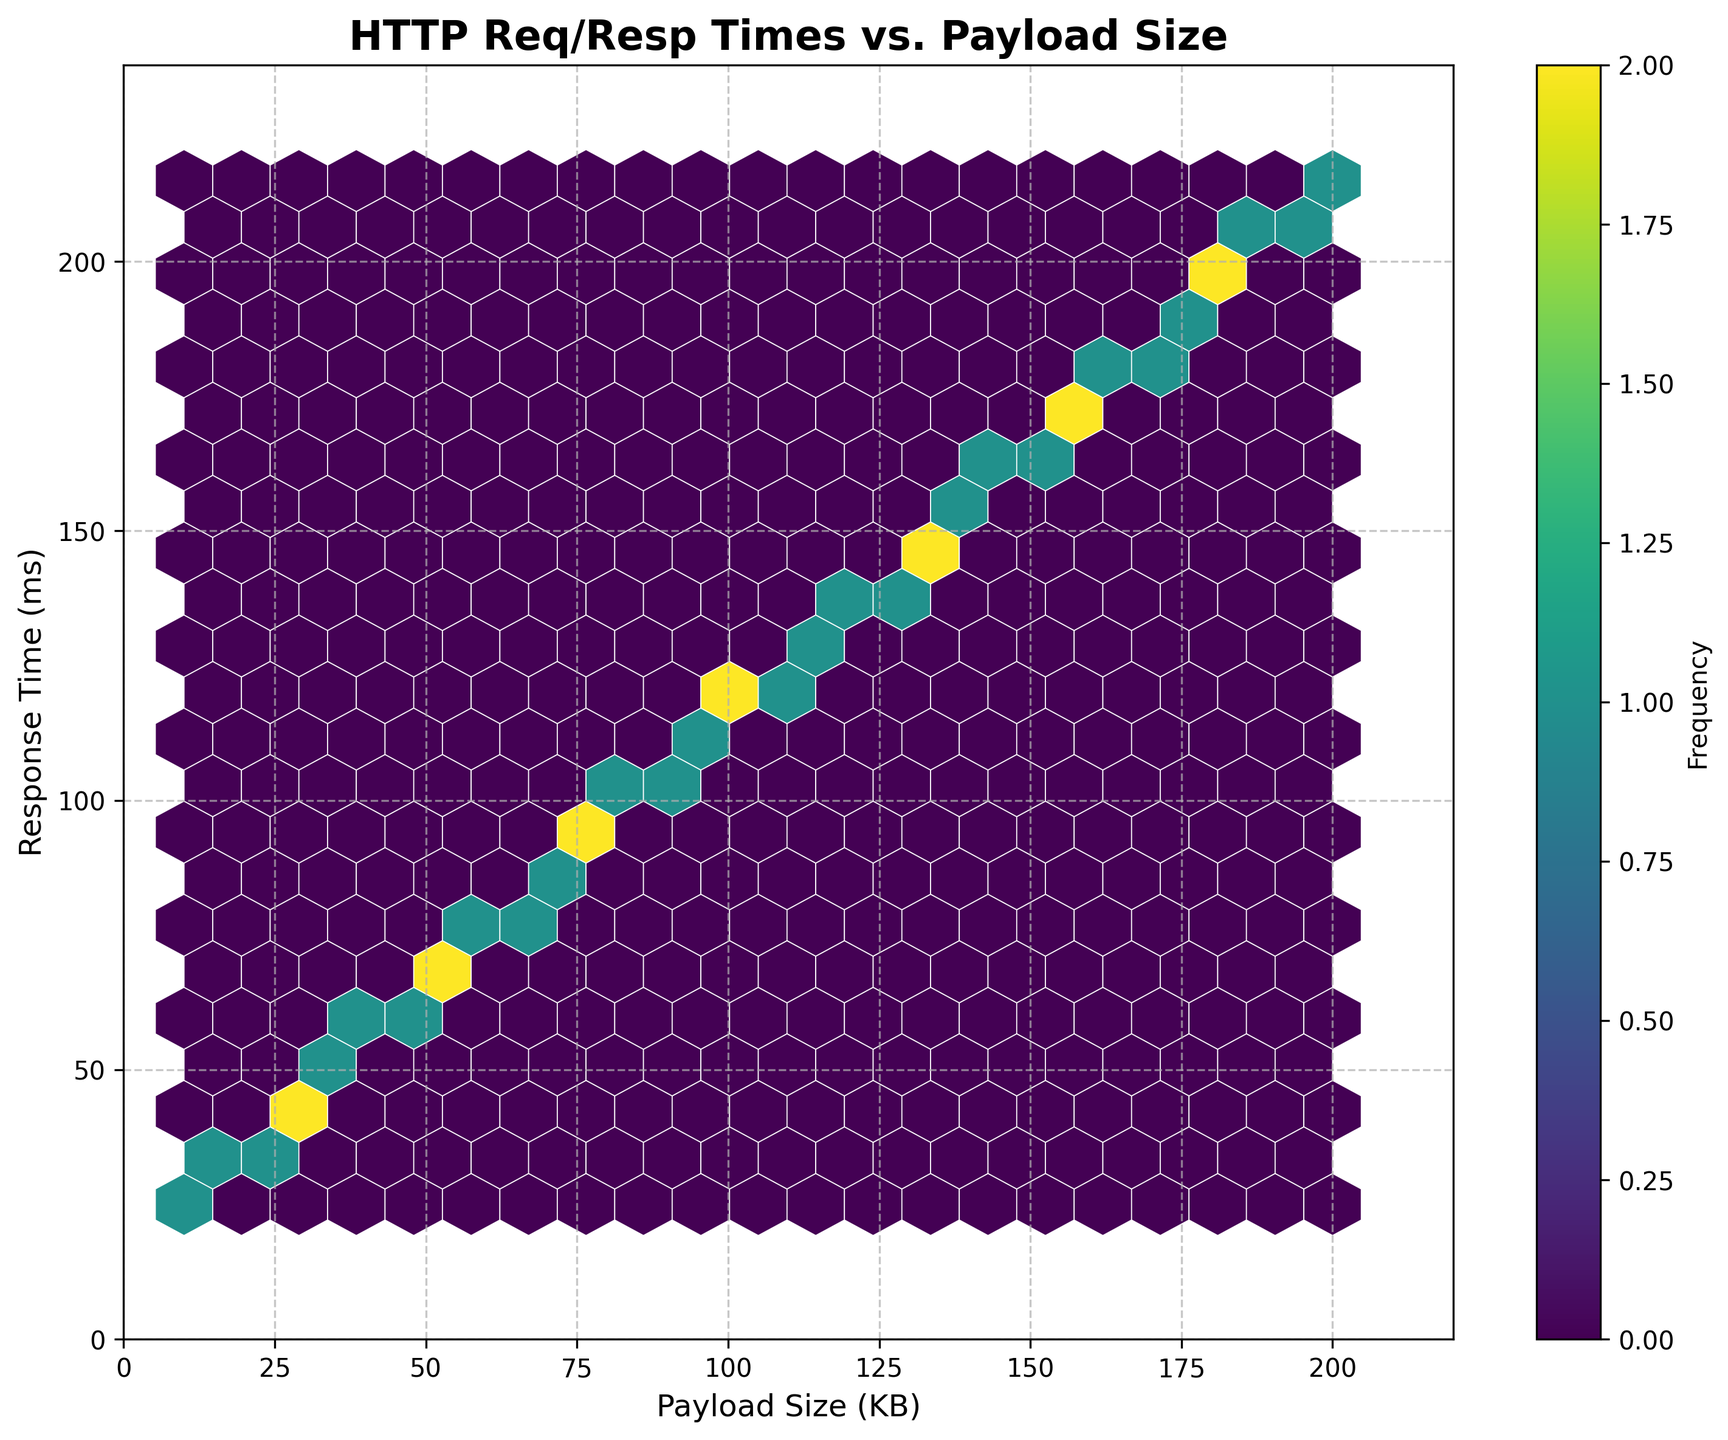How many hexagons are displayed in the plot? Count the number of hexagons visible on the plot. The gridsize is set to 20, which typically results in 20x20 hexagons, but some are empty.
Answer: 24 What are the labels of the x-axis and y-axis? Read the labels on the x-axis and y-axis in the plot. The x-axis is labeled "Payload Size (KB)" and the y-axis is labeled "Response Time (ms)".
Answer: Payload Size (KB) and Response Time (ms) What is the title of the plot? Look at the title placed above the plot. The title is "HTTP Req/Resp Times vs. Payload Size".
Answer: HTTP Req/Resp Times vs. Payload Size Which color represents the highest frequency of data points? Observe the color bar to understand which color represents the highest frequency. The darkest color in the 'viridis' colormap corresponds to the highest frequency.
Answer: Dark purple Is there a grid in the plot, and if so, what is its style? Notice the presence of a grid and its style. The gridlines are present and styled with dashed lines (--) and have an alpha (transparency) value of 0.7.
Answer: Dashed, transparent lines What is the approximate relationship between payload size and response time as shown in the plot? Look at the general trend of the hexagons in the plot. As payload size increases, response time also increases linearly.
Answer: Linear increase What's the range of payload sizes displayed in the plot? Check the x-axis limits and any additional scaling. The x-axis ranges from 0 to approximately 220 KB (including a 10% buffer).
Answer: 0 to 220 KB What is the range of response times displayed in the plot? Check the y-axis limits and any additional scaling. The y-axis ranges from 0 to approximately 240 ms (including a 10% buffer).
Answer: 0 to 240 ms Are there any outliers or anomalies in the plotted data? Look for any hexagons that stand out significantly from the trend or are isolated. There are no noticeable outliers or anomalies; the data follows a consistent linear pattern.
Answer: No outliers or anomalies Is there a color bar legend, and what does it represent? Check the right side of the plot for a color bar. The color bar is present and indicates the frequency of data points within each hexagon.
Answer: Yes, it represents frequency 